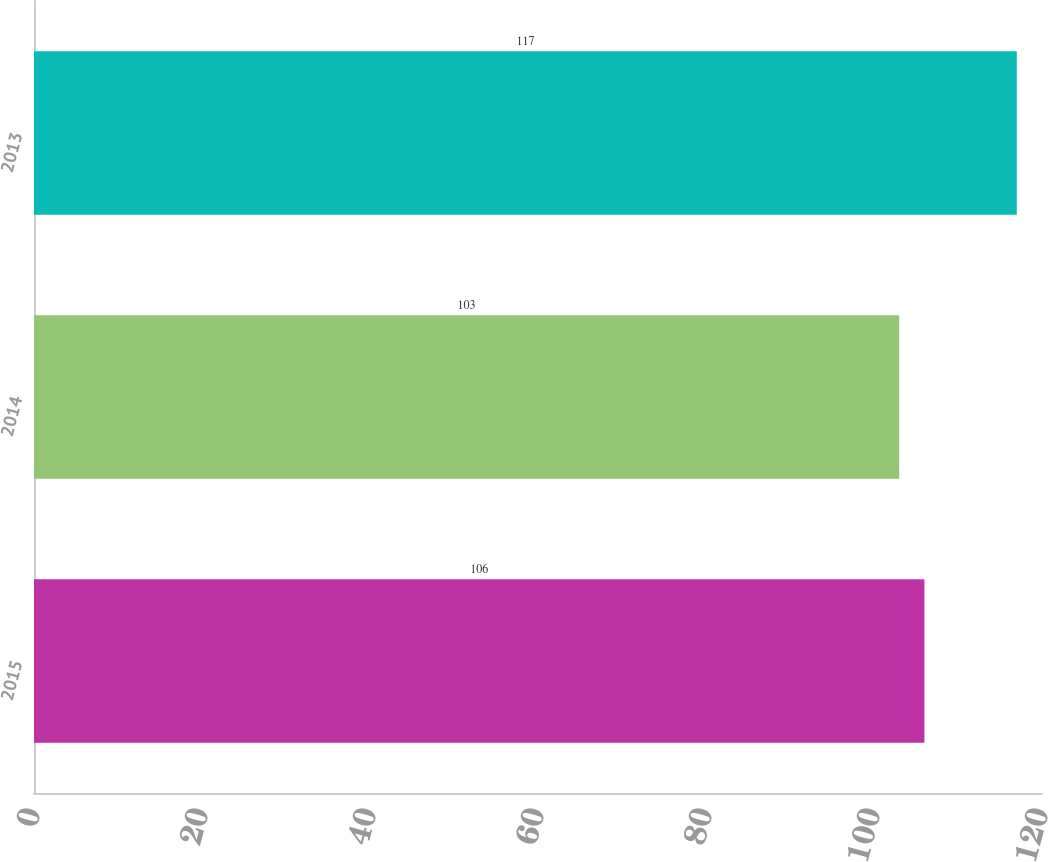Convert chart to OTSL. <chart><loc_0><loc_0><loc_500><loc_500><bar_chart><fcel>2015<fcel>2014<fcel>2013<nl><fcel>106<fcel>103<fcel>117<nl></chart> 